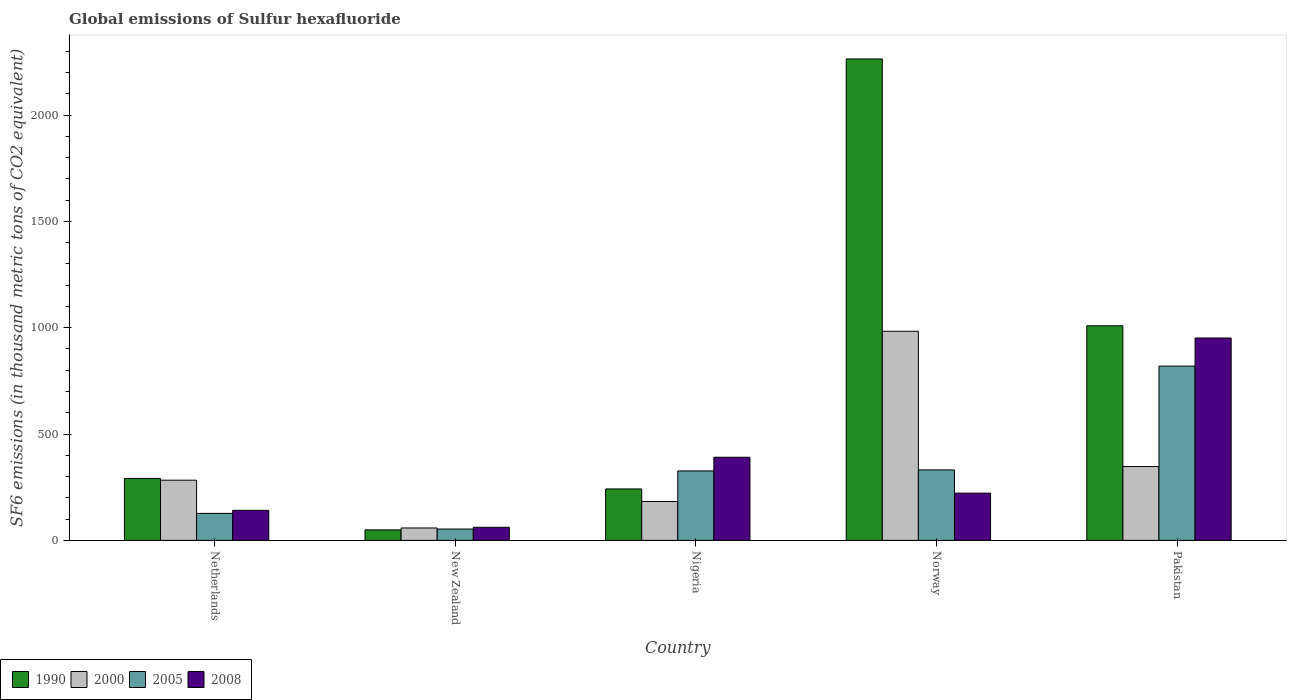Are the number of bars per tick equal to the number of legend labels?
Ensure brevity in your answer.  Yes. Are the number of bars on each tick of the X-axis equal?
Ensure brevity in your answer.  Yes. What is the label of the 2nd group of bars from the left?
Ensure brevity in your answer.  New Zealand. What is the global emissions of Sulfur hexafluoride in 2008 in Pakistan?
Your answer should be compact. 951.6. Across all countries, what is the maximum global emissions of Sulfur hexafluoride in 2008?
Your answer should be very brief. 951.6. Across all countries, what is the minimum global emissions of Sulfur hexafluoride in 2000?
Ensure brevity in your answer.  58.4. In which country was the global emissions of Sulfur hexafluoride in 2005 maximum?
Offer a very short reply. Pakistan. In which country was the global emissions of Sulfur hexafluoride in 2005 minimum?
Ensure brevity in your answer.  New Zealand. What is the total global emissions of Sulfur hexafluoride in 1990 in the graph?
Ensure brevity in your answer.  3855.2. What is the difference between the global emissions of Sulfur hexafluoride in 2008 in New Zealand and that in Norway?
Your answer should be very brief. -160.7. What is the difference between the global emissions of Sulfur hexafluoride in 2000 in New Zealand and the global emissions of Sulfur hexafluoride in 1990 in Netherlands?
Your answer should be compact. -232.9. What is the average global emissions of Sulfur hexafluoride in 1990 per country?
Provide a succinct answer. 771.04. What is the difference between the global emissions of Sulfur hexafluoride of/in 2005 and global emissions of Sulfur hexafluoride of/in 2000 in Nigeria?
Offer a very short reply. 143.8. In how many countries, is the global emissions of Sulfur hexafluoride in 2000 greater than 1100 thousand metric tons?
Offer a very short reply. 0. What is the ratio of the global emissions of Sulfur hexafluoride in 2005 in New Zealand to that in Pakistan?
Provide a succinct answer. 0.07. Is the global emissions of Sulfur hexafluoride in 2005 in Netherlands less than that in Pakistan?
Keep it short and to the point. Yes. What is the difference between the highest and the second highest global emissions of Sulfur hexafluoride in 2005?
Provide a succinct answer. -488. What is the difference between the highest and the lowest global emissions of Sulfur hexafluoride in 2008?
Your answer should be compact. 890.1. Is the sum of the global emissions of Sulfur hexafluoride in 2005 in New Zealand and Norway greater than the maximum global emissions of Sulfur hexafluoride in 2000 across all countries?
Offer a terse response. No. Is it the case that in every country, the sum of the global emissions of Sulfur hexafluoride in 1990 and global emissions of Sulfur hexafluoride in 2008 is greater than the sum of global emissions of Sulfur hexafluoride in 2005 and global emissions of Sulfur hexafluoride in 2000?
Make the answer very short. No. What does the 3rd bar from the right in Netherlands represents?
Offer a very short reply. 2000. How many bars are there?
Offer a very short reply. 20. Are all the bars in the graph horizontal?
Your response must be concise. No. How many countries are there in the graph?
Make the answer very short. 5. What is the difference between two consecutive major ticks on the Y-axis?
Keep it short and to the point. 500. Are the values on the major ticks of Y-axis written in scientific E-notation?
Your response must be concise. No. Does the graph contain grids?
Your response must be concise. No. What is the title of the graph?
Your response must be concise. Global emissions of Sulfur hexafluoride. Does "1985" appear as one of the legend labels in the graph?
Make the answer very short. No. What is the label or title of the Y-axis?
Your answer should be very brief. SF6 emissions (in thousand metric tons of CO2 equivalent). What is the SF6 emissions (in thousand metric tons of CO2 equivalent) in 1990 in Netherlands?
Offer a very short reply. 291.3. What is the SF6 emissions (in thousand metric tons of CO2 equivalent) in 2000 in Netherlands?
Provide a short and direct response. 283. What is the SF6 emissions (in thousand metric tons of CO2 equivalent) of 2005 in Netherlands?
Your answer should be compact. 126.9. What is the SF6 emissions (in thousand metric tons of CO2 equivalent) in 2008 in Netherlands?
Ensure brevity in your answer.  141.4. What is the SF6 emissions (in thousand metric tons of CO2 equivalent) of 1990 in New Zealand?
Keep it short and to the point. 49.4. What is the SF6 emissions (in thousand metric tons of CO2 equivalent) of 2000 in New Zealand?
Give a very brief answer. 58.4. What is the SF6 emissions (in thousand metric tons of CO2 equivalent) of 2005 in New Zealand?
Give a very brief answer. 53.4. What is the SF6 emissions (in thousand metric tons of CO2 equivalent) in 2008 in New Zealand?
Offer a very short reply. 61.5. What is the SF6 emissions (in thousand metric tons of CO2 equivalent) of 1990 in Nigeria?
Provide a short and direct response. 241.9. What is the SF6 emissions (in thousand metric tons of CO2 equivalent) in 2000 in Nigeria?
Offer a very short reply. 182.8. What is the SF6 emissions (in thousand metric tons of CO2 equivalent) of 2005 in Nigeria?
Your response must be concise. 326.6. What is the SF6 emissions (in thousand metric tons of CO2 equivalent) in 2008 in Nigeria?
Provide a succinct answer. 390.9. What is the SF6 emissions (in thousand metric tons of CO2 equivalent) in 1990 in Norway?
Make the answer very short. 2263.6. What is the SF6 emissions (in thousand metric tons of CO2 equivalent) in 2000 in Norway?
Make the answer very short. 983.2. What is the SF6 emissions (in thousand metric tons of CO2 equivalent) of 2005 in Norway?
Keep it short and to the point. 331.4. What is the SF6 emissions (in thousand metric tons of CO2 equivalent) of 2008 in Norway?
Keep it short and to the point. 222.2. What is the SF6 emissions (in thousand metric tons of CO2 equivalent) of 1990 in Pakistan?
Provide a succinct answer. 1009. What is the SF6 emissions (in thousand metric tons of CO2 equivalent) of 2000 in Pakistan?
Make the answer very short. 347.2. What is the SF6 emissions (in thousand metric tons of CO2 equivalent) in 2005 in Pakistan?
Provide a short and direct response. 819.4. What is the SF6 emissions (in thousand metric tons of CO2 equivalent) in 2008 in Pakistan?
Offer a terse response. 951.6. Across all countries, what is the maximum SF6 emissions (in thousand metric tons of CO2 equivalent) of 1990?
Ensure brevity in your answer.  2263.6. Across all countries, what is the maximum SF6 emissions (in thousand metric tons of CO2 equivalent) of 2000?
Offer a very short reply. 983.2. Across all countries, what is the maximum SF6 emissions (in thousand metric tons of CO2 equivalent) of 2005?
Ensure brevity in your answer.  819.4. Across all countries, what is the maximum SF6 emissions (in thousand metric tons of CO2 equivalent) of 2008?
Provide a short and direct response. 951.6. Across all countries, what is the minimum SF6 emissions (in thousand metric tons of CO2 equivalent) in 1990?
Offer a terse response. 49.4. Across all countries, what is the minimum SF6 emissions (in thousand metric tons of CO2 equivalent) in 2000?
Keep it short and to the point. 58.4. Across all countries, what is the minimum SF6 emissions (in thousand metric tons of CO2 equivalent) of 2005?
Your answer should be very brief. 53.4. Across all countries, what is the minimum SF6 emissions (in thousand metric tons of CO2 equivalent) in 2008?
Offer a terse response. 61.5. What is the total SF6 emissions (in thousand metric tons of CO2 equivalent) in 1990 in the graph?
Provide a succinct answer. 3855.2. What is the total SF6 emissions (in thousand metric tons of CO2 equivalent) in 2000 in the graph?
Your answer should be very brief. 1854.6. What is the total SF6 emissions (in thousand metric tons of CO2 equivalent) in 2005 in the graph?
Keep it short and to the point. 1657.7. What is the total SF6 emissions (in thousand metric tons of CO2 equivalent) in 2008 in the graph?
Offer a terse response. 1767.6. What is the difference between the SF6 emissions (in thousand metric tons of CO2 equivalent) in 1990 in Netherlands and that in New Zealand?
Your answer should be compact. 241.9. What is the difference between the SF6 emissions (in thousand metric tons of CO2 equivalent) in 2000 in Netherlands and that in New Zealand?
Provide a short and direct response. 224.6. What is the difference between the SF6 emissions (in thousand metric tons of CO2 equivalent) of 2005 in Netherlands and that in New Zealand?
Keep it short and to the point. 73.5. What is the difference between the SF6 emissions (in thousand metric tons of CO2 equivalent) in 2008 in Netherlands and that in New Zealand?
Provide a succinct answer. 79.9. What is the difference between the SF6 emissions (in thousand metric tons of CO2 equivalent) in 1990 in Netherlands and that in Nigeria?
Provide a succinct answer. 49.4. What is the difference between the SF6 emissions (in thousand metric tons of CO2 equivalent) in 2000 in Netherlands and that in Nigeria?
Offer a terse response. 100.2. What is the difference between the SF6 emissions (in thousand metric tons of CO2 equivalent) in 2005 in Netherlands and that in Nigeria?
Provide a succinct answer. -199.7. What is the difference between the SF6 emissions (in thousand metric tons of CO2 equivalent) of 2008 in Netherlands and that in Nigeria?
Provide a succinct answer. -249.5. What is the difference between the SF6 emissions (in thousand metric tons of CO2 equivalent) of 1990 in Netherlands and that in Norway?
Provide a short and direct response. -1972.3. What is the difference between the SF6 emissions (in thousand metric tons of CO2 equivalent) in 2000 in Netherlands and that in Norway?
Your answer should be very brief. -700.2. What is the difference between the SF6 emissions (in thousand metric tons of CO2 equivalent) in 2005 in Netherlands and that in Norway?
Give a very brief answer. -204.5. What is the difference between the SF6 emissions (in thousand metric tons of CO2 equivalent) in 2008 in Netherlands and that in Norway?
Make the answer very short. -80.8. What is the difference between the SF6 emissions (in thousand metric tons of CO2 equivalent) in 1990 in Netherlands and that in Pakistan?
Your answer should be compact. -717.7. What is the difference between the SF6 emissions (in thousand metric tons of CO2 equivalent) of 2000 in Netherlands and that in Pakistan?
Ensure brevity in your answer.  -64.2. What is the difference between the SF6 emissions (in thousand metric tons of CO2 equivalent) in 2005 in Netherlands and that in Pakistan?
Offer a very short reply. -692.5. What is the difference between the SF6 emissions (in thousand metric tons of CO2 equivalent) in 2008 in Netherlands and that in Pakistan?
Ensure brevity in your answer.  -810.2. What is the difference between the SF6 emissions (in thousand metric tons of CO2 equivalent) of 1990 in New Zealand and that in Nigeria?
Your response must be concise. -192.5. What is the difference between the SF6 emissions (in thousand metric tons of CO2 equivalent) in 2000 in New Zealand and that in Nigeria?
Provide a short and direct response. -124.4. What is the difference between the SF6 emissions (in thousand metric tons of CO2 equivalent) in 2005 in New Zealand and that in Nigeria?
Your answer should be very brief. -273.2. What is the difference between the SF6 emissions (in thousand metric tons of CO2 equivalent) of 2008 in New Zealand and that in Nigeria?
Your response must be concise. -329.4. What is the difference between the SF6 emissions (in thousand metric tons of CO2 equivalent) in 1990 in New Zealand and that in Norway?
Your response must be concise. -2214.2. What is the difference between the SF6 emissions (in thousand metric tons of CO2 equivalent) in 2000 in New Zealand and that in Norway?
Offer a terse response. -924.8. What is the difference between the SF6 emissions (in thousand metric tons of CO2 equivalent) of 2005 in New Zealand and that in Norway?
Give a very brief answer. -278. What is the difference between the SF6 emissions (in thousand metric tons of CO2 equivalent) of 2008 in New Zealand and that in Norway?
Your answer should be very brief. -160.7. What is the difference between the SF6 emissions (in thousand metric tons of CO2 equivalent) in 1990 in New Zealand and that in Pakistan?
Give a very brief answer. -959.6. What is the difference between the SF6 emissions (in thousand metric tons of CO2 equivalent) of 2000 in New Zealand and that in Pakistan?
Offer a terse response. -288.8. What is the difference between the SF6 emissions (in thousand metric tons of CO2 equivalent) of 2005 in New Zealand and that in Pakistan?
Provide a succinct answer. -766. What is the difference between the SF6 emissions (in thousand metric tons of CO2 equivalent) of 2008 in New Zealand and that in Pakistan?
Keep it short and to the point. -890.1. What is the difference between the SF6 emissions (in thousand metric tons of CO2 equivalent) of 1990 in Nigeria and that in Norway?
Ensure brevity in your answer.  -2021.7. What is the difference between the SF6 emissions (in thousand metric tons of CO2 equivalent) of 2000 in Nigeria and that in Norway?
Make the answer very short. -800.4. What is the difference between the SF6 emissions (in thousand metric tons of CO2 equivalent) in 2005 in Nigeria and that in Norway?
Give a very brief answer. -4.8. What is the difference between the SF6 emissions (in thousand metric tons of CO2 equivalent) in 2008 in Nigeria and that in Norway?
Your answer should be compact. 168.7. What is the difference between the SF6 emissions (in thousand metric tons of CO2 equivalent) of 1990 in Nigeria and that in Pakistan?
Offer a terse response. -767.1. What is the difference between the SF6 emissions (in thousand metric tons of CO2 equivalent) in 2000 in Nigeria and that in Pakistan?
Provide a succinct answer. -164.4. What is the difference between the SF6 emissions (in thousand metric tons of CO2 equivalent) of 2005 in Nigeria and that in Pakistan?
Give a very brief answer. -492.8. What is the difference between the SF6 emissions (in thousand metric tons of CO2 equivalent) of 2008 in Nigeria and that in Pakistan?
Provide a short and direct response. -560.7. What is the difference between the SF6 emissions (in thousand metric tons of CO2 equivalent) of 1990 in Norway and that in Pakistan?
Make the answer very short. 1254.6. What is the difference between the SF6 emissions (in thousand metric tons of CO2 equivalent) of 2000 in Norway and that in Pakistan?
Provide a short and direct response. 636. What is the difference between the SF6 emissions (in thousand metric tons of CO2 equivalent) of 2005 in Norway and that in Pakistan?
Your response must be concise. -488. What is the difference between the SF6 emissions (in thousand metric tons of CO2 equivalent) in 2008 in Norway and that in Pakistan?
Make the answer very short. -729.4. What is the difference between the SF6 emissions (in thousand metric tons of CO2 equivalent) in 1990 in Netherlands and the SF6 emissions (in thousand metric tons of CO2 equivalent) in 2000 in New Zealand?
Keep it short and to the point. 232.9. What is the difference between the SF6 emissions (in thousand metric tons of CO2 equivalent) in 1990 in Netherlands and the SF6 emissions (in thousand metric tons of CO2 equivalent) in 2005 in New Zealand?
Give a very brief answer. 237.9. What is the difference between the SF6 emissions (in thousand metric tons of CO2 equivalent) in 1990 in Netherlands and the SF6 emissions (in thousand metric tons of CO2 equivalent) in 2008 in New Zealand?
Offer a terse response. 229.8. What is the difference between the SF6 emissions (in thousand metric tons of CO2 equivalent) of 2000 in Netherlands and the SF6 emissions (in thousand metric tons of CO2 equivalent) of 2005 in New Zealand?
Provide a succinct answer. 229.6. What is the difference between the SF6 emissions (in thousand metric tons of CO2 equivalent) in 2000 in Netherlands and the SF6 emissions (in thousand metric tons of CO2 equivalent) in 2008 in New Zealand?
Offer a very short reply. 221.5. What is the difference between the SF6 emissions (in thousand metric tons of CO2 equivalent) of 2005 in Netherlands and the SF6 emissions (in thousand metric tons of CO2 equivalent) of 2008 in New Zealand?
Make the answer very short. 65.4. What is the difference between the SF6 emissions (in thousand metric tons of CO2 equivalent) of 1990 in Netherlands and the SF6 emissions (in thousand metric tons of CO2 equivalent) of 2000 in Nigeria?
Keep it short and to the point. 108.5. What is the difference between the SF6 emissions (in thousand metric tons of CO2 equivalent) in 1990 in Netherlands and the SF6 emissions (in thousand metric tons of CO2 equivalent) in 2005 in Nigeria?
Keep it short and to the point. -35.3. What is the difference between the SF6 emissions (in thousand metric tons of CO2 equivalent) in 1990 in Netherlands and the SF6 emissions (in thousand metric tons of CO2 equivalent) in 2008 in Nigeria?
Your response must be concise. -99.6. What is the difference between the SF6 emissions (in thousand metric tons of CO2 equivalent) of 2000 in Netherlands and the SF6 emissions (in thousand metric tons of CO2 equivalent) of 2005 in Nigeria?
Ensure brevity in your answer.  -43.6. What is the difference between the SF6 emissions (in thousand metric tons of CO2 equivalent) in 2000 in Netherlands and the SF6 emissions (in thousand metric tons of CO2 equivalent) in 2008 in Nigeria?
Offer a terse response. -107.9. What is the difference between the SF6 emissions (in thousand metric tons of CO2 equivalent) in 2005 in Netherlands and the SF6 emissions (in thousand metric tons of CO2 equivalent) in 2008 in Nigeria?
Your response must be concise. -264. What is the difference between the SF6 emissions (in thousand metric tons of CO2 equivalent) of 1990 in Netherlands and the SF6 emissions (in thousand metric tons of CO2 equivalent) of 2000 in Norway?
Your answer should be very brief. -691.9. What is the difference between the SF6 emissions (in thousand metric tons of CO2 equivalent) of 1990 in Netherlands and the SF6 emissions (in thousand metric tons of CO2 equivalent) of 2005 in Norway?
Provide a short and direct response. -40.1. What is the difference between the SF6 emissions (in thousand metric tons of CO2 equivalent) in 1990 in Netherlands and the SF6 emissions (in thousand metric tons of CO2 equivalent) in 2008 in Norway?
Offer a very short reply. 69.1. What is the difference between the SF6 emissions (in thousand metric tons of CO2 equivalent) in 2000 in Netherlands and the SF6 emissions (in thousand metric tons of CO2 equivalent) in 2005 in Norway?
Give a very brief answer. -48.4. What is the difference between the SF6 emissions (in thousand metric tons of CO2 equivalent) of 2000 in Netherlands and the SF6 emissions (in thousand metric tons of CO2 equivalent) of 2008 in Norway?
Give a very brief answer. 60.8. What is the difference between the SF6 emissions (in thousand metric tons of CO2 equivalent) in 2005 in Netherlands and the SF6 emissions (in thousand metric tons of CO2 equivalent) in 2008 in Norway?
Your answer should be compact. -95.3. What is the difference between the SF6 emissions (in thousand metric tons of CO2 equivalent) in 1990 in Netherlands and the SF6 emissions (in thousand metric tons of CO2 equivalent) in 2000 in Pakistan?
Your answer should be very brief. -55.9. What is the difference between the SF6 emissions (in thousand metric tons of CO2 equivalent) of 1990 in Netherlands and the SF6 emissions (in thousand metric tons of CO2 equivalent) of 2005 in Pakistan?
Keep it short and to the point. -528.1. What is the difference between the SF6 emissions (in thousand metric tons of CO2 equivalent) of 1990 in Netherlands and the SF6 emissions (in thousand metric tons of CO2 equivalent) of 2008 in Pakistan?
Keep it short and to the point. -660.3. What is the difference between the SF6 emissions (in thousand metric tons of CO2 equivalent) in 2000 in Netherlands and the SF6 emissions (in thousand metric tons of CO2 equivalent) in 2005 in Pakistan?
Your response must be concise. -536.4. What is the difference between the SF6 emissions (in thousand metric tons of CO2 equivalent) in 2000 in Netherlands and the SF6 emissions (in thousand metric tons of CO2 equivalent) in 2008 in Pakistan?
Keep it short and to the point. -668.6. What is the difference between the SF6 emissions (in thousand metric tons of CO2 equivalent) in 2005 in Netherlands and the SF6 emissions (in thousand metric tons of CO2 equivalent) in 2008 in Pakistan?
Keep it short and to the point. -824.7. What is the difference between the SF6 emissions (in thousand metric tons of CO2 equivalent) in 1990 in New Zealand and the SF6 emissions (in thousand metric tons of CO2 equivalent) in 2000 in Nigeria?
Your answer should be very brief. -133.4. What is the difference between the SF6 emissions (in thousand metric tons of CO2 equivalent) of 1990 in New Zealand and the SF6 emissions (in thousand metric tons of CO2 equivalent) of 2005 in Nigeria?
Your response must be concise. -277.2. What is the difference between the SF6 emissions (in thousand metric tons of CO2 equivalent) of 1990 in New Zealand and the SF6 emissions (in thousand metric tons of CO2 equivalent) of 2008 in Nigeria?
Your answer should be compact. -341.5. What is the difference between the SF6 emissions (in thousand metric tons of CO2 equivalent) of 2000 in New Zealand and the SF6 emissions (in thousand metric tons of CO2 equivalent) of 2005 in Nigeria?
Make the answer very short. -268.2. What is the difference between the SF6 emissions (in thousand metric tons of CO2 equivalent) in 2000 in New Zealand and the SF6 emissions (in thousand metric tons of CO2 equivalent) in 2008 in Nigeria?
Give a very brief answer. -332.5. What is the difference between the SF6 emissions (in thousand metric tons of CO2 equivalent) of 2005 in New Zealand and the SF6 emissions (in thousand metric tons of CO2 equivalent) of 2008 in Nigeria?
Give a very brief answer. -337.5. What is the difference between the SF6 emissions (in thousand metric tons of CO2 equivalent) in 1990 in New Zealand and the SF6 emissions (in thousand metric tons of CO2 equivalent) in 2000 in Norway?
Ensure brevity in your answer.  -933.8. What is the difference between the SF6 emissions (in thousand metric tons of CO2 equivalent) in 1990 in New Zealand and the SF6 emissions (in thousand metric tons of CO2 equivalent) in 2005 in Norway?
Your response must be concise. -282. What is the difference between the SF6 emissions (in thousand metric tons of CO2 equivalent) of 1990 in New Zealand and the SF6 emissions (in thousand metric tons of CO2 equivalent) of 2008 in Norway?
Make the answer very short. -172.8. What is the difference between the SF6 emissions (in thousand metric tons of CO2 equivalent) in 2000 in New Zealand and the SF6 emissions (in thousand metric tons of CO2 equivalent) in 2005 in Norway?
Offer a very short reply. -273. What is the difference between the SF6 emissions (in thousand metric tons of CO2 equivalent) in 2000 in New Zealand and the SF6 emissions (in thousand metric tons of CO2 equivalent) in 2008 in Norway?
Provide a short and direct response. -163.8. What is the difference between the SF6 emissions (in thousand metric tons of CO2 equivalent) of 2005 in New Zealand and the SF6 emissions (in thousand metric tons of CO2 equivalent) of 2008 in Norway?
Give a very brief answer. -168.8. What is the difference between the SF6 emissions (in thousand metric tons of CO2 equivalent) in 1990 in New Zealand and the SF6 emissions (in thousand metric tons of CO2 equivalent) in 2000 in Pakistan?
Give a very brief answer. -297.8. What is the difference between the SF6 emissions (in thousand metric tons of CO2 equivalent) in 1990 in New Zealand and the SF6 emissions (in thousand metric tons of CO2 equivalent) in 2005 in Pakistan?
Keep it short and to the point. -770. What is the difference between the SF6 emissions (in thousand metric tons of CO2 equivalent) of 1990 in New Zealand and the SF6 emissions (in thousand metric tons of CO2 equivalent) of 2008 in Pakistan?
Ensure brevity in your answer.  -902.2. What is the difference between the SF6 emissions (in thousand metric tons of CO2 equivalent) in 2000 in New Zealand and the SF6 emissions (in thousand metric tons of CO2 equivalent) in 2005 in Pakistan?
Ensure brevity in your answer.  -761. What is the difference between the SF6 emissions (in thousand metric tons of CO2 equivalent) of 2000 in New Zealand and the SF6 emissions (in thousand metric tons of CO2 equivalent) of 2008 in Pakistan?
Give a very brief answer. -893.2. What is the difference between the SF6 emissions (in thousand metric tons of CO2 equivalent) of 2005 in New Zealand and the SF6 emissions (in thousand metric tons of CO2 equivalent) of 2008 in Pakistan?
Give a very brief answer. -898.2. What is the difference between the SF6 emissions (in thousand metric tons of CO2 equivalent) in 1990 in Nigeria and the SF6 emissions (in thousand metric tons of CO2 equivalent) in 2000 in Norway?
Ensure brevity in your answer.  -741.3. What is the difference between the SF6 emissions (in thousand metric tons of CO2 equivalent) in 1990 in Nigeria and the SF6 emissions (in thousand metric tons of CO2 equivalent) in 2005 in Norway?
Keep it short and to the point. -89.5. What is the difference between the SF6 emissions (in thousand metric tons of CO2 equivalent) in 1990 in Nigeria and the SF6 emissions (in thousand metric tons of CO2 equivalent) in 2008 in Norway?
Provide a short and direct response. 19.7. What is the difference between the SF6 emissions (in thousand metric tons of CO2 equivalent) in 2000 in Nigeria and the SF6 emissions (in thousand metric tons of CO2 equivalent) in 2005 in Norway?
Offer a very short reply. -148.6. What is the difference between the SF6 emissions (in thousand metric tons of CO2 equivalent) in 2000 in Nigeria and the SF6 emissions (in thousand metric tons of CO2 equivalent) in 2008 in Norway?
Provide a short and direct response. -39.4. What is the difference between the SF6 emissions (in thousand metric tons of CO2 equivalent) in 2005 in Nigeria and the SF6 emissions (in thousand metric tons of CO2 equivalent) in 2008 in Norway?
Ensure brevity in your answer.  104.4. What is the difference between the SF6 emissions (in thousand metric tons of CO2 equivalent) in 1990 in Nigeria and the SF6 emissions (in thousand metric tons of CO2 equivalent) in 2000 in Pakistan?
Keep it short and to the point. -105.3. What is the difference between the SF6 emissions (in thousand metric tons of CO2 equivalent) of 1990 in Nigeria and the SF6 emissions (in thousand metric tons of CO2 equivalent) of 2005 in Pakistan?
Offer a very short reply. -577.5. What is the difference between the SF6 emissions (in thousand metric tons of CO2 equivalent) in 1990 in Nigeria and the SF6 emissions (in thousand metric tons of CO2 equivalent) in 2008 in Pakistan?
Give a very brief answer. -709.7. What is the difference between the SF6 emissions (in thousand metric tons of CO2 equivalent) of 2000 in Nigeria and the SF6 emissions (in thousand metric tons of CO2 equivalent) of 2005 in Pakistan?
Your answer should be very brief. -636.6. What is the difference between the SF6 emissions (in thousand metric tons of CO2 equivalent) in 2000 in Nigeria and the SF6 emissions (in thousand metric tons of CO2 equivalent) in 2008 in Pakistan?
Your answer should be compact. -768.8. What is the difference between the SF6 emissions (in thousand metric tons of CO2 equivalent) in 2005 in Nigeria and the SF6 emissions (in thousand metric tons of CO2 equivalent) in 2008 in Pakistan?
Your answer should be very brief. -625. What is the difference between the SF6 emissions (in thousand metric tons of CO2 equivalent) of 1990 in Norway and the SF6 emissions (in thousand metric tons of CO2 equivalent) of 2000 in Pakistan?
Offer a very short reply. 1916.4. What is the difference between the SF6 emissions (in thousand metric tons of CO2 equivalent) in 1990 in Norway and the SF6 emissions (in thousand metric tons of CO2 equivalent) in 2005 in Pakistan?
Give a very brief answer. 1444.2. What is the difference between the SF6 emissions (in thousand metric tons of CO2 equivalent) of 1990 in Norway and the SF6 emissions (in thousand metric tons of CO2 equivalent) of 2008 in Pakistan?
Ensure brevity in your answer.  1312. What is the difference between the SF6 emissions (in thousand metric tons of CO2 equivalent) of 2000 in Norway and the SF6 emissions (in thousand metric tons of CO2 equivalent) of 2005 in Pakistan?
Make the answer very short. 163.8. What is the difference between the SF6 emissions (in thousand metric tons of CO2 equivalent) in 2000 in Norway and the SF6 emissions (in thousand metric tons of CO2 equivalent) in 2008 in Pakistan?
Your answer should be very brief. 31.6. What is the difference between the SF6 emissions (in thousand metric tons of CO2 equivalent) in 2005 in Norway and the SF6 emissions (in thousand metric tons of CO2 equivalent) in 2008 in Pakistan?
Offer a very short reply. -620.2. What is the average SF6 emissions (in thousand metric tons of CO2 equivalent) in 1990 per country?
Ensure brevity in your answer.  771.04. What is the average SF6 emissions (in thousand metric tons of CO2 equivalent) of 2000 per country?
Your response must be concise. 370.92. What is the average SF6 emissions (in thousand metric tons of CO2 equivalent) in 2005 per country?
Ensure brevity in your answer.  331.54. What is the average SF6 emissions (in thousand metric tons of CO2 equivalent) of 2008 per country?
Your response must be concise. 353.52. What is the difference between the SF6 emissions (in thousand metric tons of CO2 equivalent) in 1990 and SF6 emissions (in thousand metric tons of CO2 equivalent) in 2000 in Netherlands?
Provide a succinct answer. 8.3. What is the difference between the SF6 emissions (in thousand metric tons of CO2 equivalent) of 1990 and SF6 emissions (in thousand metric tons of CO2 equivalent) of 2005 in Netherlands?
Provide a succinct answer. 164.4. What is the difference between the SF6 emissions (in thousand metric tons of CO2 equivalent) in 1990 and SF6 emissions (in thousand metric tons of CO2 equivalent) in 2008 in Netherlands?
Provide a short and direct response. 149.9. What is the difference between the SF6 emissions (in thousand metric tons of CO2 equivalent) in 2000 and SF6 emissions (in thousand metric tons of CO2 equivalent) in 2005 in Netherlands?
Ensure brevity in your answer.  156.1. What is the difference between the SF6 emissions (in thousand metric tons of CO2 equivalent) of 2000 and SF6 emissions (in thousand metric tons of CO2 equivalent) of 2008 in Netherlands?
Provide a succinct answer. 141.6. What is the difference between the SF6 emissions (in thousand metric tons of CO2 equivalent) of 2005 and SF6 emissions (in thousand metric tons of CO2 equivalent) of 2008 in Netherlands?
Your answer should be compact. -14.5. What is the difference between the SF6 emissions (in thousand metric tons of CO2 equivalent) of 1990 and SF6 emissions (in thousand metric tons of CO2 equivalent) of 2000 in New Zealand?
Provide a succinct answer. -9. What is the difference between the SF6 emissions (in thousand metric tons of CO2 equivalent) of 1990 and SF6 emissions (in thousand metric tons of CO2 equivalent) of 2005 in New Zealand?
Your response must be concise. -4. What is the difference between the SF6 emissions (in thousand metric tons of CO2 equivalent) in 1990 and SF6 emissions (in thousand metric tons of CO2 equivalent) in 2008 in New Zealand?
Provide a succinct answer. -12.1. What is the difference between the SF6 emissions (in thousand metric tons of CO2 equivalent) in 1990 and SF6 emissions (in thousand metric tons of CO2 equivalent) in 2000 in Nigeria?
Offer a terse response. 59.1. What is the difference between the SF6 emissions (in thousand metric tons of CO2 equivalent) in 1990 and SF6 emissions (in thousand metric tons of CO2 equivalent) in 2005 in Nigeria?
Make the answer very short. -84.7. What is the difference between the SF6 emissions (in thousand metric tons of CO2 equivalent) of 1990 and SF6 emissions (in thousand metric tons of CO2 equivalent) of 2008 in Nigeria?
Provide a short and direct response. -149. What is the difference between the SF6 emissions (in thousand metric tons of CO2 equivalent) of 2000 and SF6 emissions (in thousand metric tons of CO2 equivalent) of 2005 in Nigeria?
Your response must be concise. -143.8. What is the difference between the SF6 emissions (in thousand metric tons of CO2 equivalent) of 2000 and SF6 emissions (in thousand metric tons of CO2 equivalent) of 2008 in Nigeria?
Your answer should be very brief. -208.1. What is the difference between the SF6 emissions (in thousand metric tons of CO2 equivalent) in 2005 and SF6 emissions (in thousand metric tons of CO2 equivalent) in 2008 in Nigeria?
Your response must be concise. -64.3. What is the difference between the SF6 emissions (in thousand metric tons of CO2 equivalent) of 1990 and SF6 emissions (in thousand metric tons of CO2 equivalent) of 2000 in Norway?
Give a very brief answer. 1280.4. What is the difference between the SF6 emissions (in thousand metric tons of CO2 equivalent) in 1990 and SF6 emissions (in thousand metric tons of CO2 equivalent) in 2005 in Norway?
Provide a short and direct response. 1932.2. What is the difference between the SF6 emissions (in thousand metric tons of CO2 equivalent) of 1990 and SF6 emissions (in thousand metric tons of CO2 equivalent) of 2008 in Norway?
Give a very brief answer. 2041.4. What is the difference between the SF6 emissions (in thousand metric tons of CO2 equivalent) of 2000 and SF6 emissions (in thousand metric tons of CO2 equivalent) of 2005 in Norway?
Provide a succinct answer. 651.8. What is the difference between the SF6 emissions (in thousand metric tons of CO2 equivalent) of 2000 and SF6 emissions (in thousand metric tons of CO2 equivalent) of 2008 in Norway?
Keep it short and to the point. 761. What is the difference between the SF6 emissions (in thousand metric tons of CO2 equivalent) in 2005 and SF6 emissions (in thousand metric tons of CO2 equivalent) in 2008 in Norway?
Ensure brevity in your answer.  109.2. What is the difference between the SF6 emissions (in thousand metric tons of CO2 equivalent) in 1990 and SF6 emissions (in thousand metric tons of CO2 equivalent) in 2000 in Pakistan?
Make the answer very short. 661.8. What is the difference between the SF6 emissions (in thousand metric tons of CO2 equivalent) of 1990 and SF6 emissions (in thousand metric tons of CO2 equivalent) of 2005 in Pakistan?
Give a very brief answer. 189.6. What is the difference between the SF6 emissions (in thousand metric tons of CO2 equivalent) in 1990 and SF6 emissions (in thousand metric tons of CO2 equivalent) in 2008 in Pakistan?
Keep it short and to the point. 57.4. What is the difference between the SF6 emissions (in thousand metric tons of CO2 equivalent) of 2000 and SF6 emissions (in thousand metric tons of CO2 equivalent) of 2005 in Pakistan?
Make the answer very short. -472.2. What is the difference between the SF6 emissions (in thousand metric tons of CO2 equivalent) of 2000 and SF6 emissions (in thousand metric tons of CO2 equivalent) of 2008 in Pakistan?
Your response must be concise. -604.4. What is the difference between the SF6 emissions (in thousand metric tons of CO2 equivalent) of 2005 and SF6 emissions (in thousand metric tons of CO2 equivalent) of 2008 in Pakistan?
Give a very brief answer. -132.2. What is the ratio of the SF6 emissions (in thousand metric tons of CO2 equivalent) in 1990 in Netherlands to that in New Zealand?
Make the answer very short. 5.9. What is the ratio of the SF6 emissions (in thousand metric tons of CO2 equivalent) of 2000 in Netherlands to that in New Zealand?
Your answer should be compact. 4.85. What is the ratio of the SF6 emissions (in thousand metric tons of CO2 equivalent) in 2005 in Netherlands to that in New Zealand?
Offer a very short reply. 2.38. What is the ratio of the SF6 emissions (in thousand metric tons of CO2 equivalent) in 2008 in Netherlands to that in New Zealand?
Give a very brief answer. 2.3. What is the ratio of the SF6 emissions (in thousand metric tons of CO2 equivalent) of 1990 in Netherlands to that in Nigeria?
Offer a very short reply. 1.2. What is the ratio of the SF6 emissions (in thousand metric tons of CO2 equivalent) of 2000 in Netherlands to that in Nigeria?
Provide a short and direct response. 1.55. What is the ratio of the SF6 emissions (in thousand metric tons of CO2 equivalent) in 2005 in Netherlands to that in Nigeria?
Your response must be concise. 0.39. What is the ratio of the SF6 emissions (in thousand metric tons of CO2 equivalent) in 2008 in Netherlands to that in Nigeria?
Offer a very short reply. 0.36. What is the ratio of the SF6 emissions (in thousand metric tons of CO2 equivalent) in 1990 in Netherlands to that in Norway?
Make the answer very short. 0.13. What is the ratio of the SF6 emissions (in thousand metric tons of CO2 equivalent) in 2000 in Netherlands to that in Norway?
Provide a short and direct response. 0.29. What is the ratio of the SF6 emissions (in thousand metric tons of CO2 equivalent) in 2005 in Netherlands to that in Norway?
Offer a terse response. 0.38. What is the ratio of the SF6 emissions (in thousand metric tons of CO2 equivalent) in 2008 in Netherlands to that in Norway?
Offer a terse response. 0.64. What is the ratio of the SF6 emissions (in thousand metric tons of CO2 equivalent) of 1990 in Netherlands to that in Pakistan?
Ensure brevity in your answer.  0.29. What is the ratio of the SF6 emissions (in thousand metric tons of CO2 equivalent) in 2000 in Netherlands to that in Pakistan?
Keep it short and to the point. 0.82. What is the ratio of the SF6 emissions (in thousand metric tons of CO2 equivalent) in 2005 in Netherlands to that in Pakistan?
Provide a short and direct response. 0.15. What is the ratio of the SF6 emissions (in thousand metric tons of CO2 equivalent) in 2008 in Netherlands to that in Pakistan?
Make the answer very short. 0.15. What is the ratio of the SF6 emissions (in thousand metric tons of CO2 equivalent) of 1990 in New Zealand to that in Nigeria?
Provide a short and direct response. 0.2. What is the ratio of the SF6 emissions (in thousand metric tons of CO2 equivalent) in 2000 in New Zealand to that in Nigeria?
Keep it short and to the point. 0.32. What is the ratio of the SF6 emissions (in thousand metric tons of CO2 equivalent) of 2005 in New Zealand to that in Nigeria?
Your response must be concise. 0.16. What is the ratio of the SF6 emissions (in thousand metric tons of CO2 equivalent) in 2008 in New Zealand to that in Nigeria?
Keep it short and to the point. 0.16. What is the ratio of the SF6 emissions (in thousand metric tons of CO2 equivalent) in 1990 in New Zealand to that in Norway?
Give a very brief answer. 0.02. What is the ratio of the SF6 emissions (in thousand metric tons of CO2 equivalent) of 2000 in New Zealand to that in Norway?
Give a very brief answer. 0.06. What is the ratio of the SF6 emissions (in thousand metric tons of CO2 equivalent) in 2005 in New Zealand to that in Norway?
Offer a very short reply. 0.16. What is the ratio of the SF6 emissions (in thousand metric tons of CO2 equivalent) of 2008 in New Zealand to that in Norway?
Provide a succinct answer. 0.28. What is the ratio of the SF6 emissions (in thousand metric tons of CO2 equivalent) of 1990 in New Zealand to that in Pakistan?
Offer a terse response. 0.05. What is the ratio of the SF6 emissions (in thousand metric tons of CO2 equivalent) in 2000 in New Zealand to that in Pakistan?
Offer a terse response. 0.17. What is the ratio of the SF6 emissions (in thousand metric tons of CO2 equivalent) of 2005 in New Zealand to that in Pakistan?
Offer a terse response. 0.07. What is the ratio of the SF6 emissions (in thousand metric tons of CO2 equivalent) of 2008 in New Zealand to that in Pakistan?
Keep it short and to the point. 0.06. What is the ratio of the SF6 emissions (in thousand metric tons of CO2 equivalent) of 1990 in Nigeria to that in Norway?
Ensure brevity in your answer.  0.11. What is the ratio of the SF6 emissions (in thousand metric tons of CO2 equivalent) in 2000 in Nigeria to that in Norway?
Your answer should be compact. 0.19. What is the ratio of the SF6 emissions (in thousand metric tons of CO2 equivalent) of 2005 in Nigeria to that in Norway?
Keep it short and to the point. 0.99. What is the ratio of the SF6 emissions (in thousand metric tons of CO2 equivalent) in 2008 in Nigeria to that in Norway?
Your answer should be very brief. 1.76. What is the ratio of the SF6 emissions (in thousand metric tons of CO2 equivalent) of 1990 in Nigeria to that in Pakistan?
Keep it short and to the point. 0.24. What is the ratio of the SF6 emissions (in thousand metric tons of CO2 equivalent) in 2000 in Nigeria to that in Pakistan?
Give a very brief answer. 0.53. What is the ratio of the SF6 emissions (in thousand metric tons of CO2 equivalent) of 2005 in Nigeria to that in Pakistan?
Your response must be concise. 0.4. What is the ratio of the SF6 emissions (in thousand metric tons of CO2 equivalent) in 2008 in Nigeria to that in Pakistan?
Make the answer very short. 0.41. What is the ratio of the SF6 emissions (in thousand metric tons of CO2 equivalent) of 1990 in Norway to that in Pakistan?
Your response must be concise. 2.24. What is the ratio of the SF6 emissions (in thousand metric tons of CO2 equivalent) of 2000 in Norway to that in Pakistan?
Ensure brevity in your answer.  2.83. What is the ratio of the SF6 emissions (in thousand metric tons of CO2 equivalent) in 2005 in Norway to that in Pakistan?
Provide a short and direct response. 0.4. What is the ratio of the SF6 emissions (in thousand metric tons of CO2 equivalent) of 2008 in Norway to that in Pakistan?
Your answer should be very brief. 0.23. What is the difference between the highest and the second highest SF6 emissions (in thousand metric tons of CO2 equivalent) in 1990?
Make the answer very short. 1254.6. What is the difference between the highest and the second highest SF6 emissions (in thousand metric tons of CO2 equivalent) of 2000?
Provide a succinct answer. 636. What is the difference between the highest and the second highest SF6 emissions (in thousand metric tons of CO2 equivalent) of 2005?
Ensure brevity in your answer.  488. What is the difference between the highest and the second highest SF6 emissions (in thousand metric tons of CO2 equivalent) in 2008?
Give a very brief answer. 560.7. What is the difference between the highest and the lowest SF6 emissions (in thousand metric tons of CO2 equivalent) in 1990?
Provide a short and direct response. 2214.2. What is the difference between the highest and the lowest SF6 emissions (in thousand metric tons of CO2 equivalent) in 2000?
Keep it short and to the point. 924.8. What is the difference between the highest and the lowest SF6 emissions (in thousand metric tons of CO2 equivalent) in 2005?
Keep it short and to the point. 766. What is the difference between the highest and the lowest SF6 emissions (in thousand metric tons of CO2 equivalent) in 2008?
Your answer should be very brief. 890.1. 